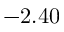<formula> <loc_0><loc_0><loc_500><loc_500>- 2 . 4 0</formula> 